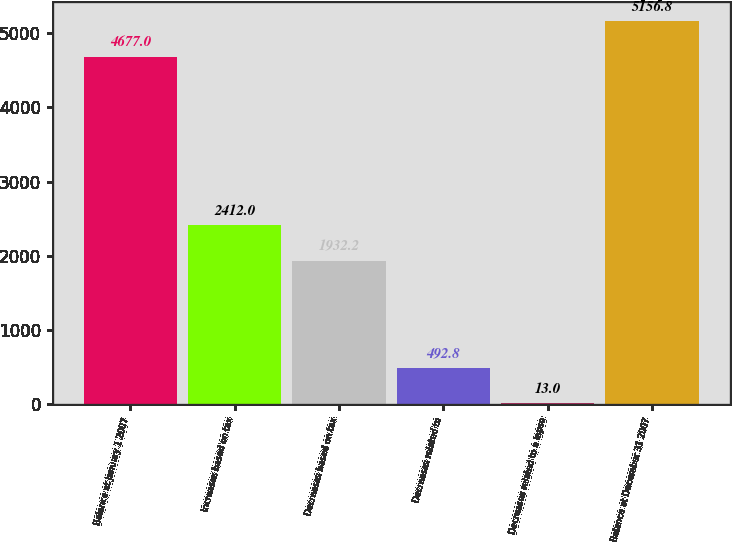Convert chart to OTSL. <chart><loc_0><loc_0><loc_500><loc_500><bar_chart><fcel>Balance at January 1 2007<fcel>Increases based on tax<fcel>Decreases based on tax<fcel>Decreases related to<fcel>Decreases related to a lapse<fcel>Balance at December 31 2007<nl><fcel>4677<fcel>2412<fcel>1932.2<fcel>492.8<fcel>13<fcel>5156.8<nl></chart> 